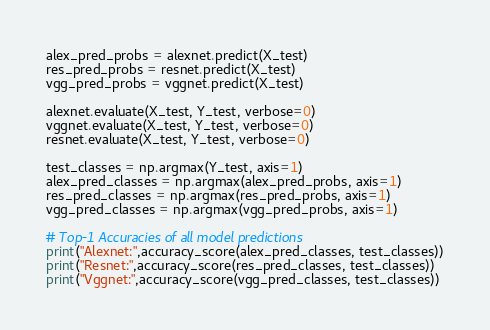Convert code to text. <code><loc_0><loc_0><loc_500><loc_500><_Python_>
alex_pred_probs = alexnet.predict(X_test)
res_pred_probs = resnet.predict(X_test)
vgg_pred_probs = vggnet.predict(X_test)

alexnet.evaluate(X_test, Y_test, verbose=0)
vggnet.evaluate(X_test, Y_test, verbose=0)
resnet.evaluate(X_test, Y_test, verbose=0)

test_classes = np.argmax(Y_test, axis=1)
alex_pred_classes = np.argmax(alex_pred_probs, axis=1)
res_pred_classes = np.argmax(res_pred_probs, axis=1)
vgg_pred_classes = np.argmax(vgg_pred_probs, axis=1)

# Top-1 Accuracies of all model predictions
print("Alexnet:",accuracy_score(alex_pred_classes, test_classes))
print("Resnet:",accuracy_score(res_pred_classes, test_classes))
print("Vggnet:",accuracy_score(vgg_pred_classes, test_classes))
</code> 